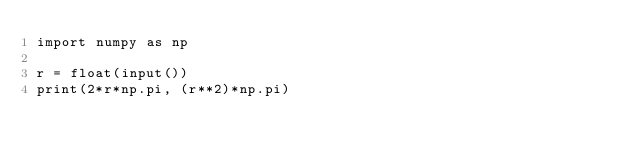Convert code to text. <code><loc_0><loc_0><loc_500><loc_500><_Python_>import numpy as np

r = float(input())
print(2*r*np.pi, (r**2)*np.pi)
</code> 